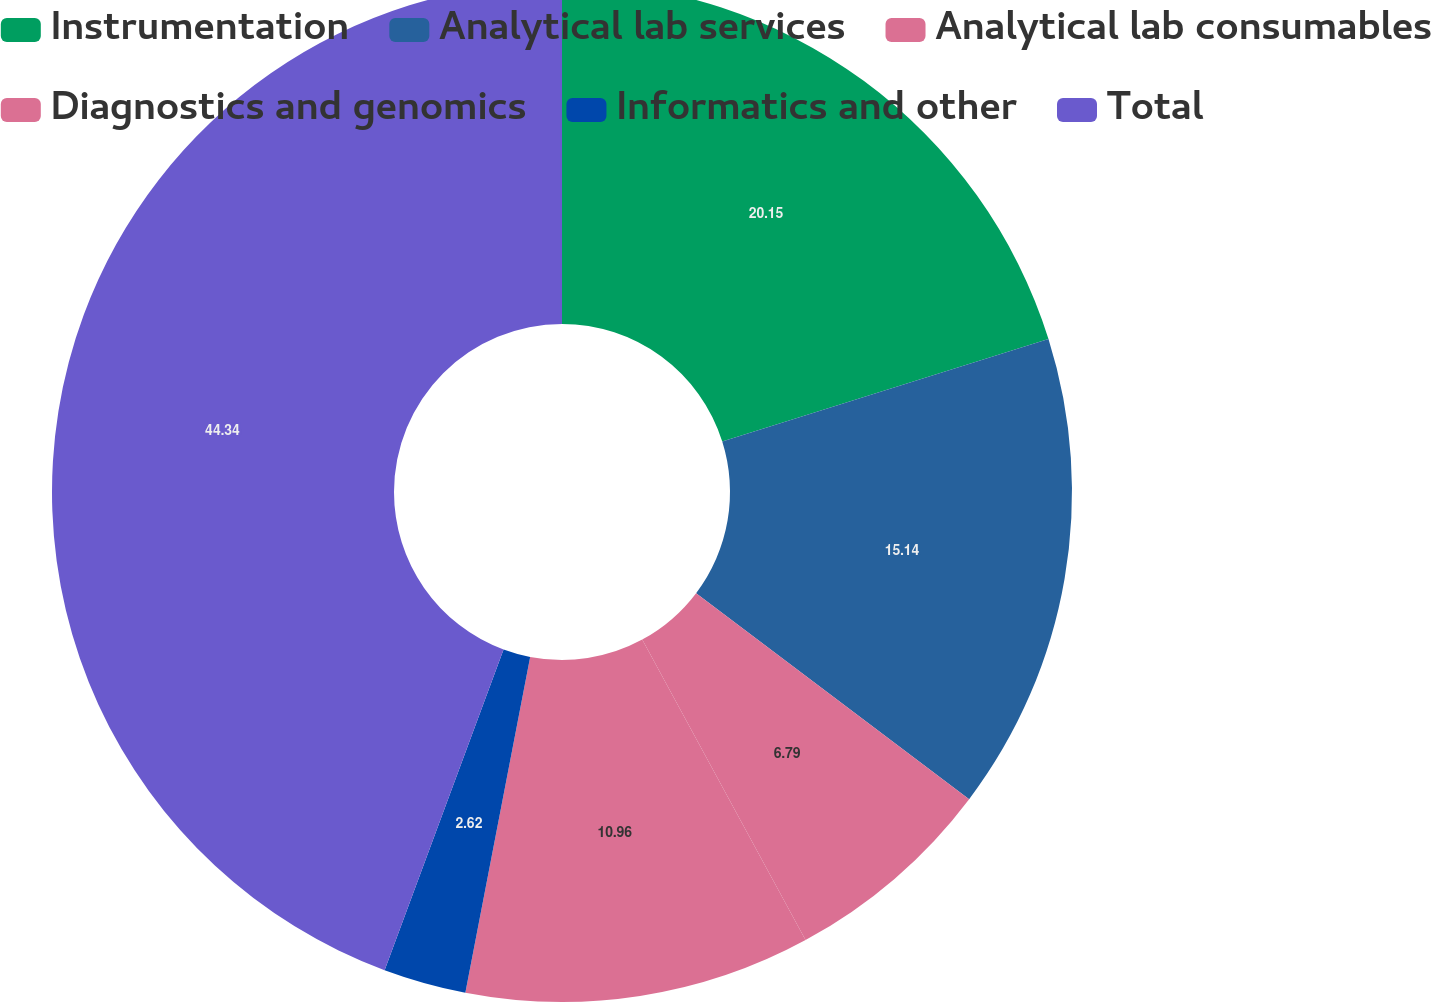<chart> <loc_0><loc_0><loc_500><loc_500><pie_chart><fcel>Instrumentation<fcel>Analytical lab services<fcel>Analytical lab consumables<fcel>Diagnostics and genomics<fcel>Informatics and other<fcel>Total<nl><fcel>20.15%<fcel>15.14%<fcel>6.79%<fcel>10.96%<fcel>2.62%<fcel>44.35%<nl></chart> 